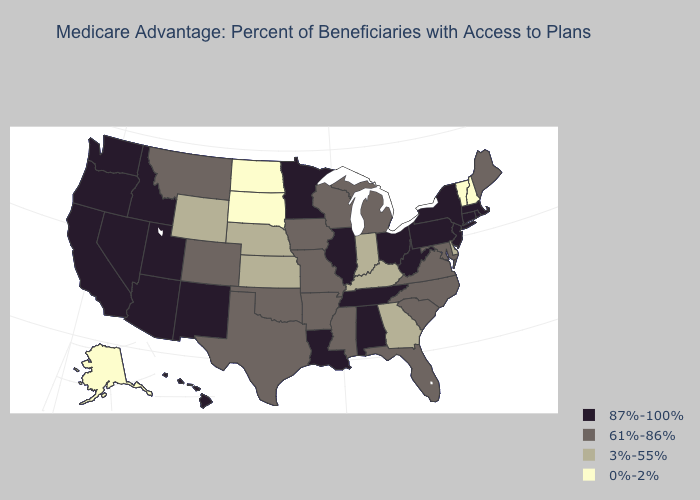What is the lowest value in states that border New Mexico?
Concise answer only. 61%-86%. Among the states that border Minnesota , which have the lowest value?
Short answer required. North Dakota, South Dakota. How many symbols are there in the legend?
Quick response, please. 4. What is the highest value in the South ?
Quick response, please. 87%-100%. What is the value of Maryland?
Short answer required. 61%-86%. What is the highest value in states that border Missouri?
Give a very brief answer. 87%-100%. Does South Carolina have the lowest value in the USA?
Give a very brief answer. No. Name the states that have a value in the range 87%-100%?
Concise answer only. Alabama, Arizona, California, Connecticut, Hawaii, Idaho, Illinois, Louisiana, Massachusetts, Minnesota, New Jersey, New Mexico, Nevada, New York, Ohio, Oregon, Pennsylvania, Rhode Island, Tennessee, Utah, Washington, West Virginia. What is the value of North Carolina?
Answer briefly. 61%-86%. What is the value of Georgia?
Quick response, please. 3%-55%. Does Mississippi have the same value as Hawaii?
Quick response, please. No. What is the value of Washington?
Be succinct. 87%-100%. What is the value of Massachusetts?
Be succinct. 87%-100%. Name the states that have a value in the range 3%-55%?
Write a very short answer. Delaware, Georgia, Indiana, Kansas, Kentucky, Nebraska, Wyoming. Name the states that have a value in the range 0%-2%?
Give a very brief answer. Alaska, North Dakota, New Hampshire, South Dakota, Vermont. 